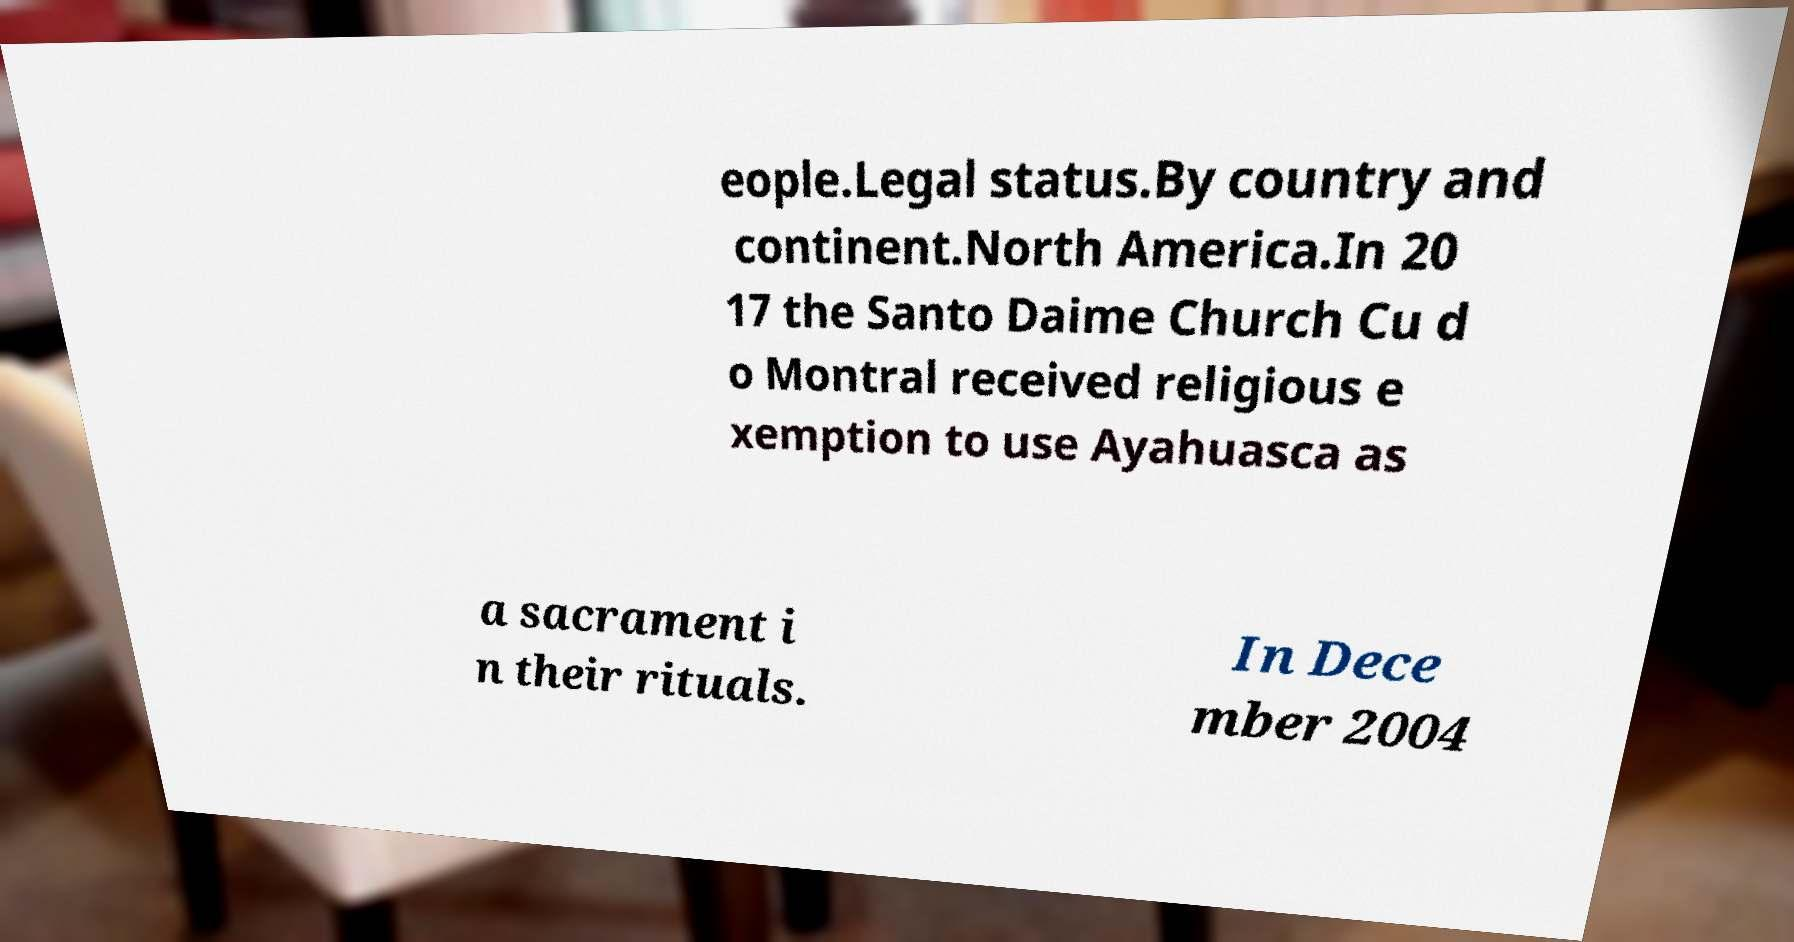Could you extract and type out the text from this image? eople.Legal status.By country and continent.North America.In 20 17 the Santo Daime Church Cu d o Montral received religious e xemption to use Ayahuasca as a sacrament i n their rituals. In Dece mber 2004 